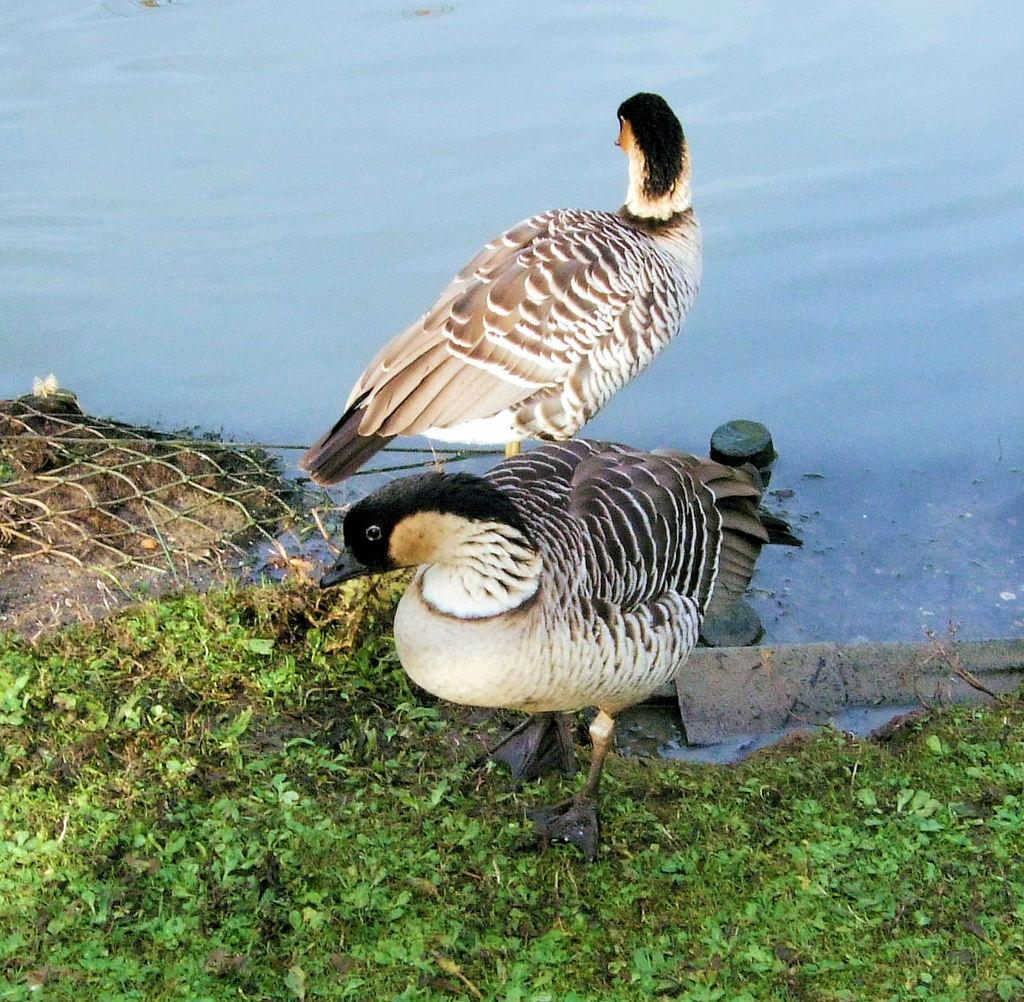How many ducks are present in the image? There are two ducks on the ground in the image. What is the purpose of the net in the image? The purpose of the net is not specified in the image, but it could be used for catching or containing the ducks or other objects. Can you describe any other objects in the image besides the ducks and net? Yes, there are other objects in the image, but their specific details are not mentioned in the provided facts. What can be seen in the background of the image? Water is visible in the image, which suggests that the ducks and other objects might be near a body of water. Where is the desk located in the image? There is no desk present in the image. What type of music is the band playing in the background of the image? There is no band or music present in the image. 